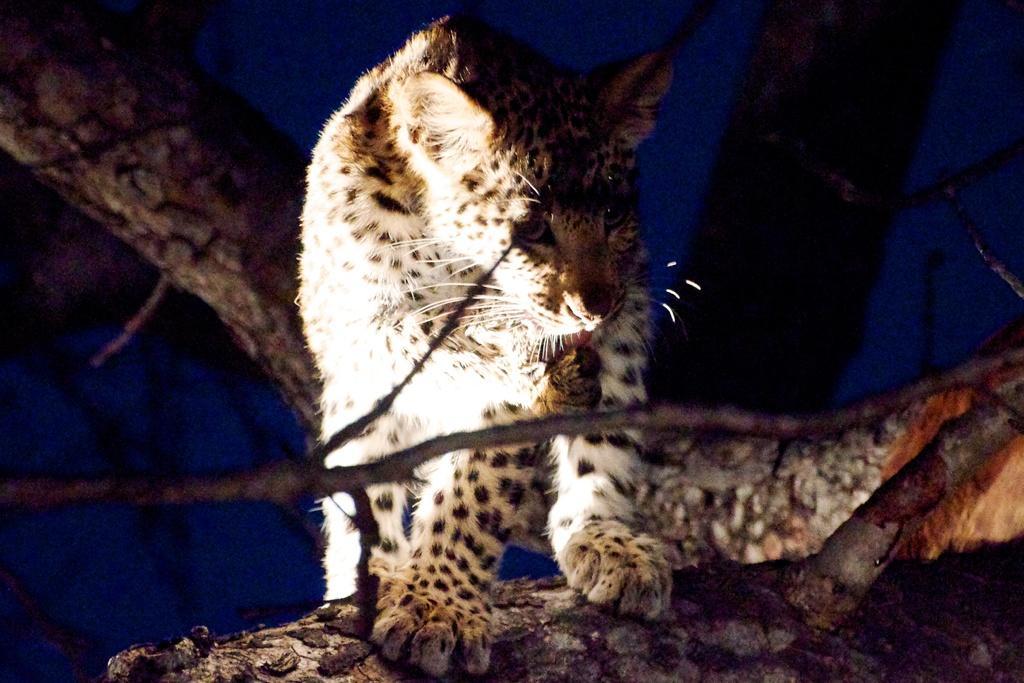Please provide a concise description of this image. In the center of the image an animal is present on a tree. In the background of the image we can see blue color. 